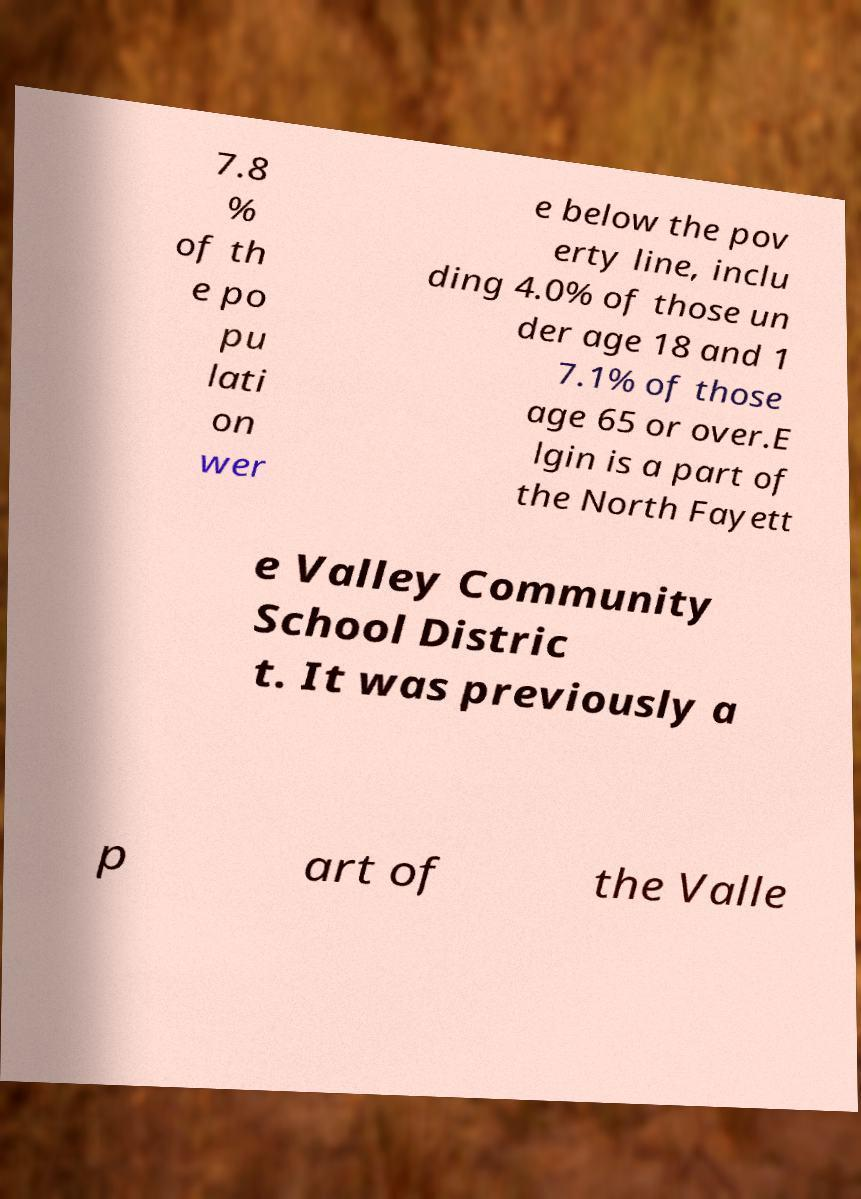There's text embedded in this image that I need extracted. Can you transcribe it verbatim? 7.8 % of th e po pu lati on wer e below the pov erty line, inclu ding 4.0% of those un der age 18 and 1 7.1% of those age 65 or over.E lgin is a part of the North Fayett e Valley Community School Distric t. It was previously a p art of the Valle 